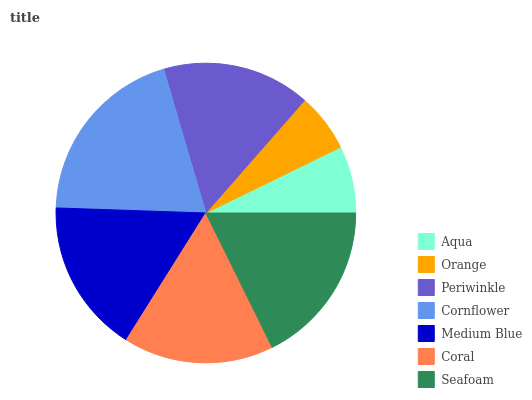Is Orange the minimum?
Answer yes or no. Yes. Is Cornflower the maximum?
Answer yes or no. Yes. Is Periwinkle the minimum?
Answer yes or no. No. Is Periwinkle the maximum?
Answer yes or no. No. Is Periwinkle greater than Orange?
Answer yes or no. Yes. Is Orange less than Periwinkle?
Answer yes or no. Yes. Is Orange greater than Periwinkle?
Answer yes or no. No. Is Periwinkle less than Orange?
Answer yes or no. No. Is Coral the high median?
Answer yes or no. Yes. Is Coral the low median?
Answer yes or no. Yes. Is Medium Blue the high median?
Answer yes or no. No. Is Orange the low median?
Answer yes or no. No. 